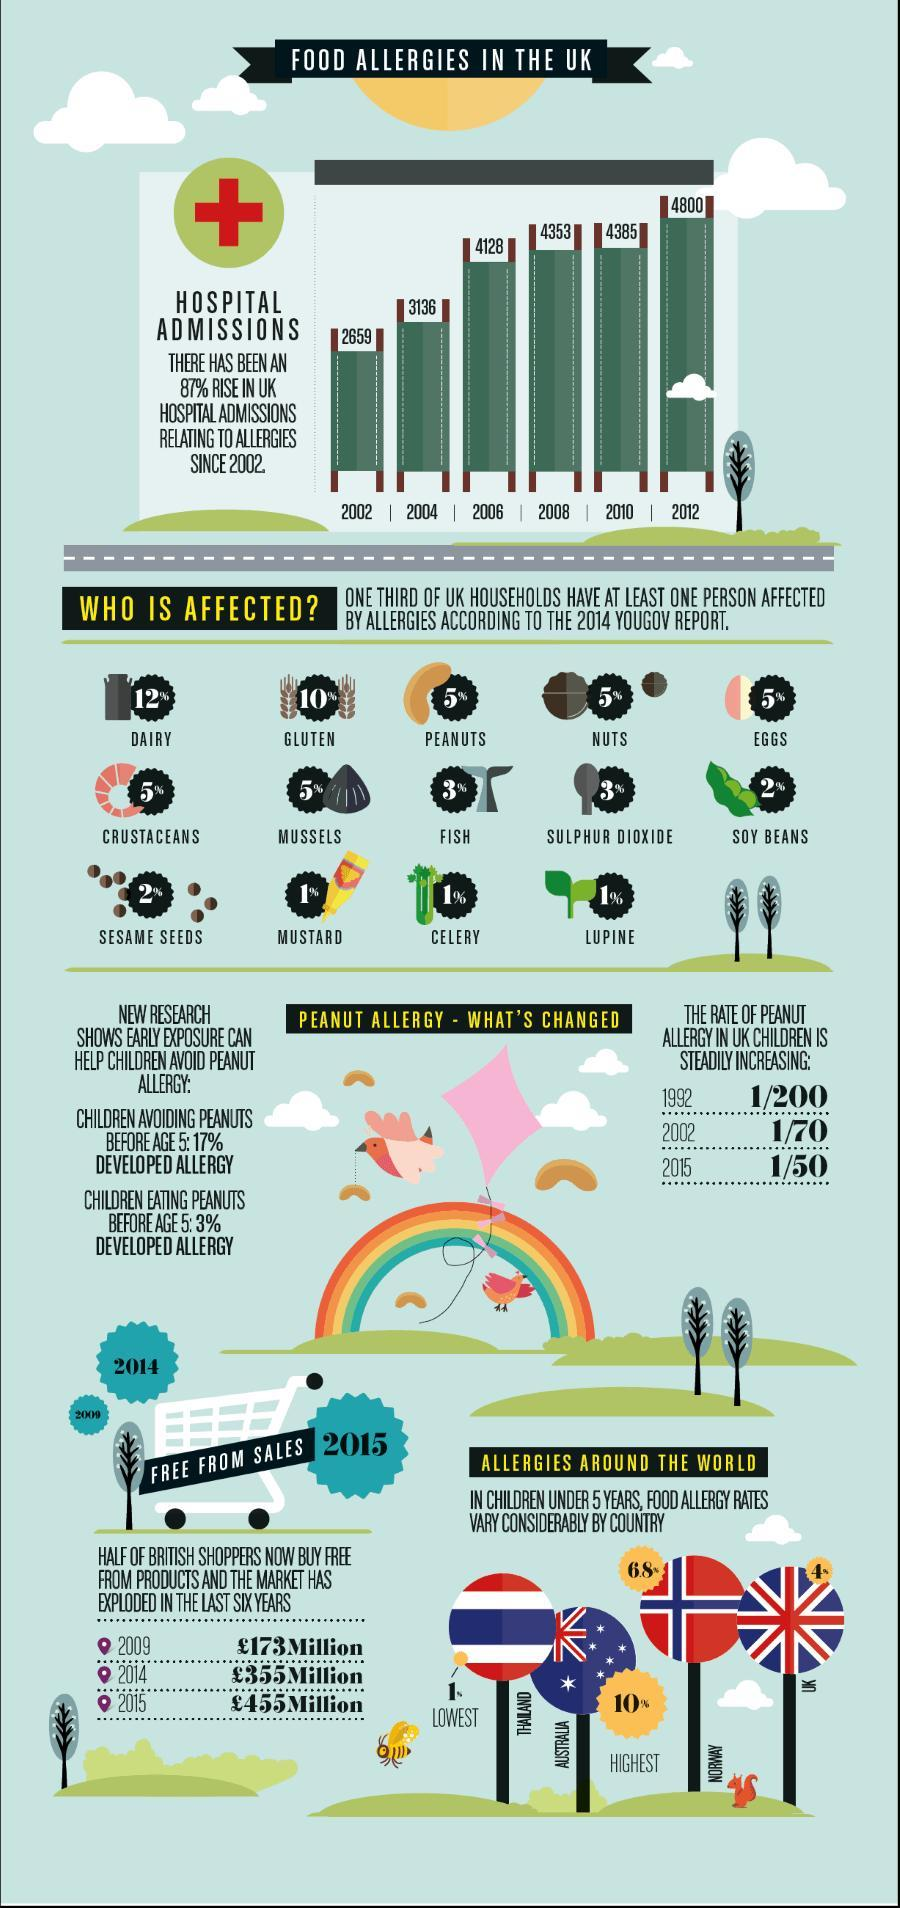Which year reported highest number of hospital admissions relating to food allergies in UK since 2002?
Answer the question with a short phrase. 2012 What percentage of UK people have diary allergy according to the 2014 Yougov report? 12% What percentage of UK people have peanut allergy according to the 2014 Yougov report? 5% What is the number of hospital admissions relating to food allergies in UK in 2010? 4385 What is the food allergy rate in children under five in UK? 4% Which country has the lowest food allergy rate in children under five? THAILAND What is the food allergy rate of children under five in Norway? 6.8% What is the rate of peanut allergy in UK children in 2002? 1/70 Which country has the highest food allergy rate in children under five? AUSTRALIA What percentage of UK people have gluten allergy according to the 2014 Yougov report? 10% 